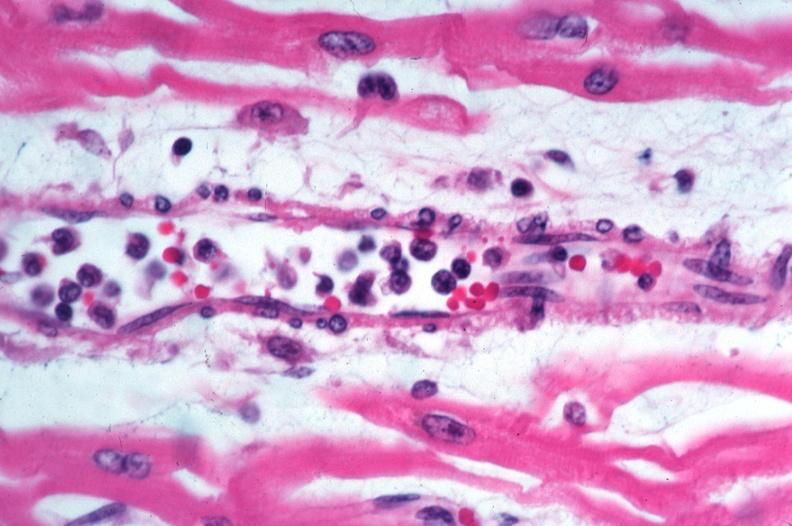what spotted fever, vasculitis?
Answer the question using a single word or phrase. Rocky mountain 